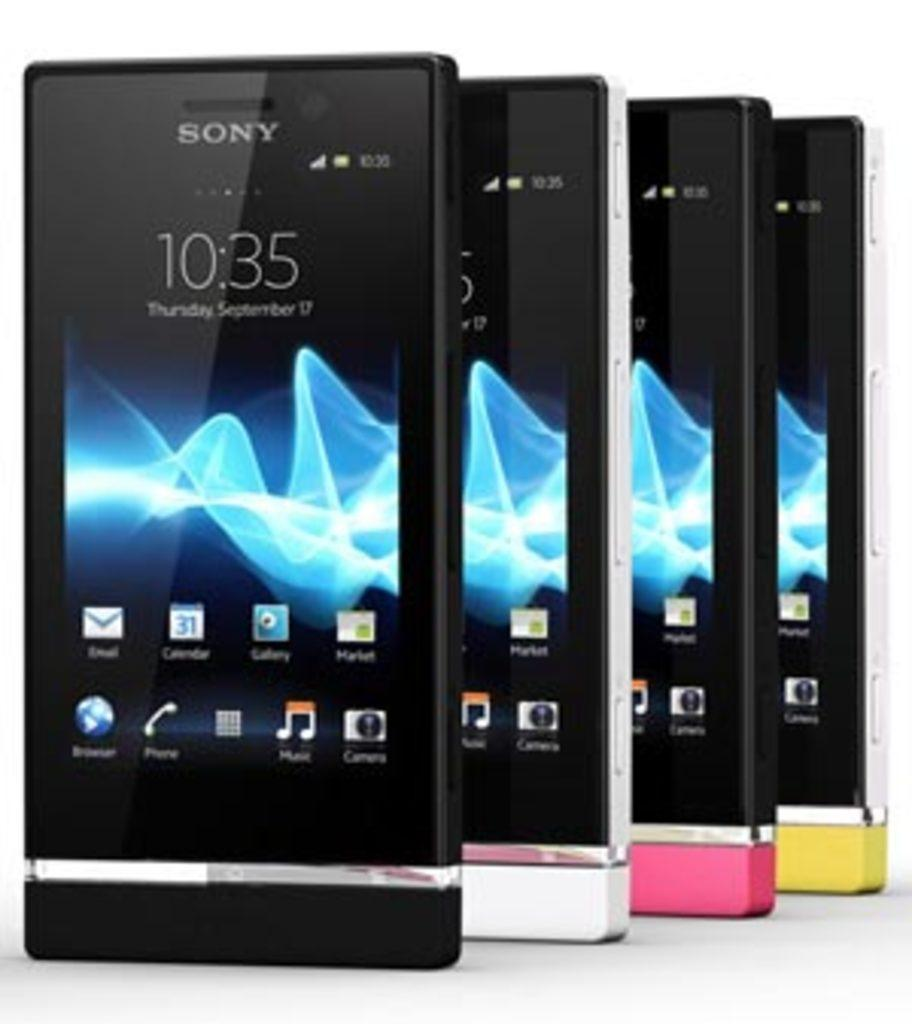Provide a one-sentence caption for the provided image. Several Sony mobile devices sit in front of a white background at 10:35 on Septmber 17. 